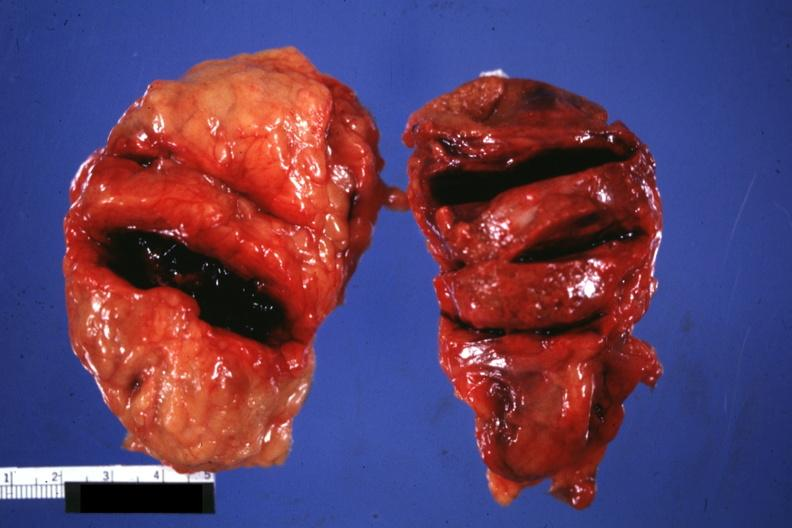how is external view of gland with knife cuts into parenchyma hemorrhage?
Answer the question using a single word or phrase. Obvious 